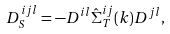Convert formula to latex. <formula><loc_0><loc_0><loc_500><loc_500>D _ { S } ^ { i j l } = - D ^ { i l } { \hat { \Sigma } } _ { T } ^ { i j } ( k ) D ^ { j l } ,</formula> 